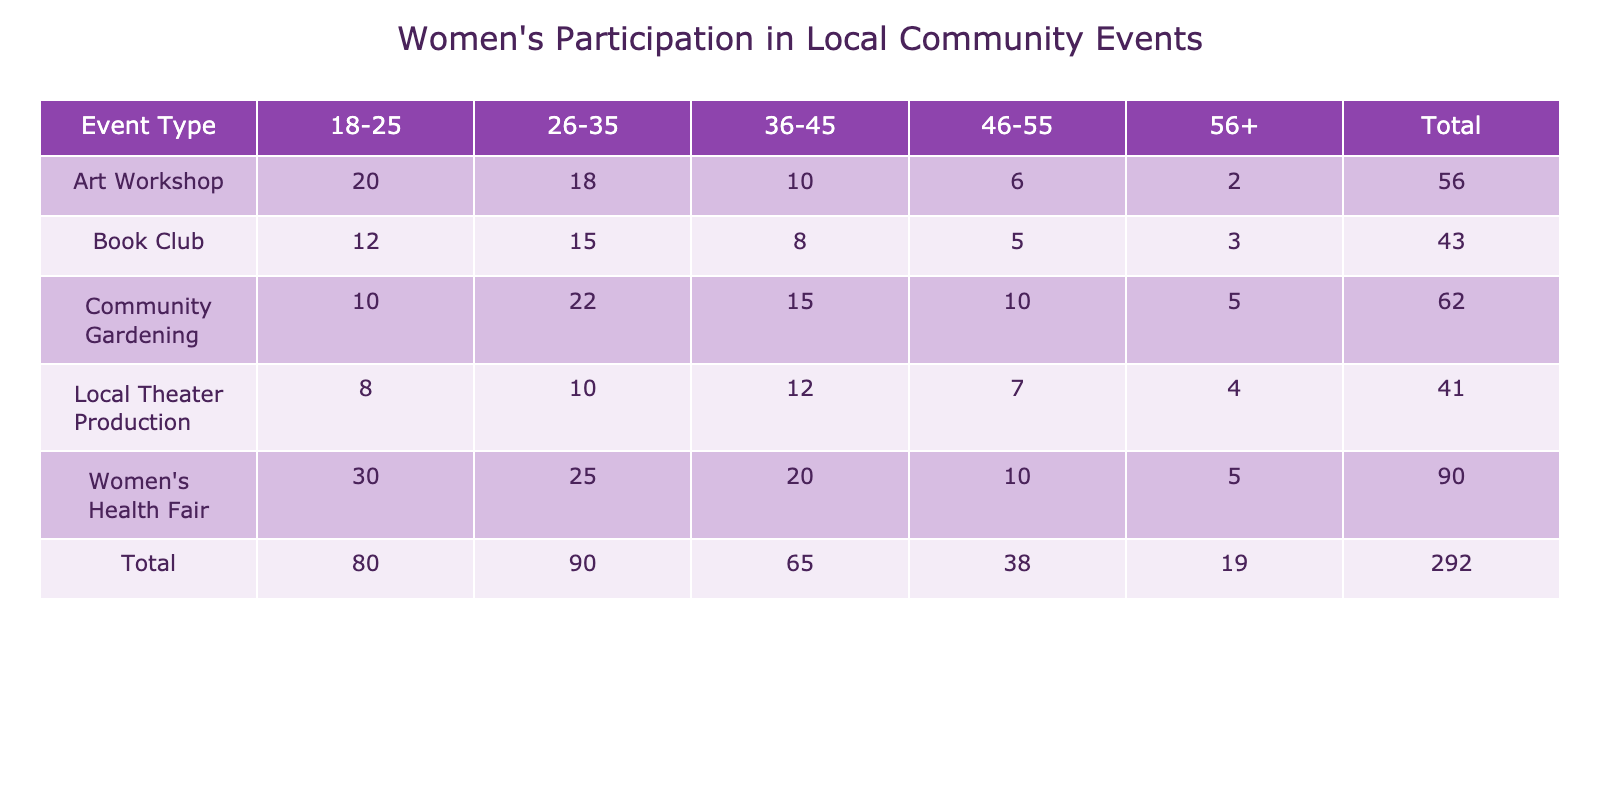What is the total participation count for the Women's Health Fair? To find the total participation count for the Women's Health Fair, I look at the row for this event type and add all the participation counts across age groups, which are 30 + 25 + 20 + 10 + 5 = 90.
Answer: 90 Which age group participated the most in the Art Workshop? In the Art Workshop row, I compare the participation counts across age groups: 20 (18-25), 18 (26-35), 10 (36-45), 6 (46-55), and 2 (56+). The highest number is 20, which is from the 18-25 age group.
Answer: 18-25 How does the participation of women in Community Gardening compare between the 26-35 and 36-45 age groups? I compare the participation counts for these two age groups within the Community Gardening row: the 26-35 age group has 22 participants, while the 36-45 age group has 15 participants. Since 22 is greater than 15, the 26-35 age group has more participation.
Answer: 26-35 has more participation What is the average participation count for women aged 46-55 across all event types? To find the average participation count for the 46-55 age group, I first identify the counts: 5 (Book Club), 6 (Art Workshop), 10 (Community Gardening), 7 (Local Theater Production), and 10 (Women's Health Fair). I sum these counts: 5 + 6 + 10 + 7 + 10 = 38, and then divide by the number of event types (5) to calculate the average: 38 / 5 = 7.6.
Answer: 7.6 Is it true that the participation in the Local Theater Production by the 56+ age group is more than the participation in the Women's Health Fair in the same age group? I check the Local Theater Production row: the 56+ age group has 4 participants. Then, I check the Women's Health Fair row: the 56+ age group has 5 participants. Since 4 is less than 5, the statement is false.
Answer: No What is the total participation count for all age groups in the Book Club? I look at the participation counts in the Book Club row: 12 (18-25), 15 (26-35), 8 (36-45), 5 (46-55), and 3 (56+). Adding these together gives: 12 + 15 + 8 + 5 + 3 = 43.
Answer: 43 Which event type had the least participation from the 56+ age group? I check the participation counts across all event types for the 56+ age group: 3 (Book Club), 2 (Art Workshop), 5 (Community Gardening), 4 (Local Theater Production), and 5 (Women's Health Fair). The lowest is 2, which is from the Art Workshop.
Answer: Art Workshop What is the total participation of women in the 18-25 age group across all events? To find this total, I add the participation counts for the 18-25 age group in each event: 12 (Book Club) + 20 (Art Workshop) + 10 (Community Gardening) + 8 (Local Theater Production) + 30 (Women's Health Fair) = 80.
Answer: 80 